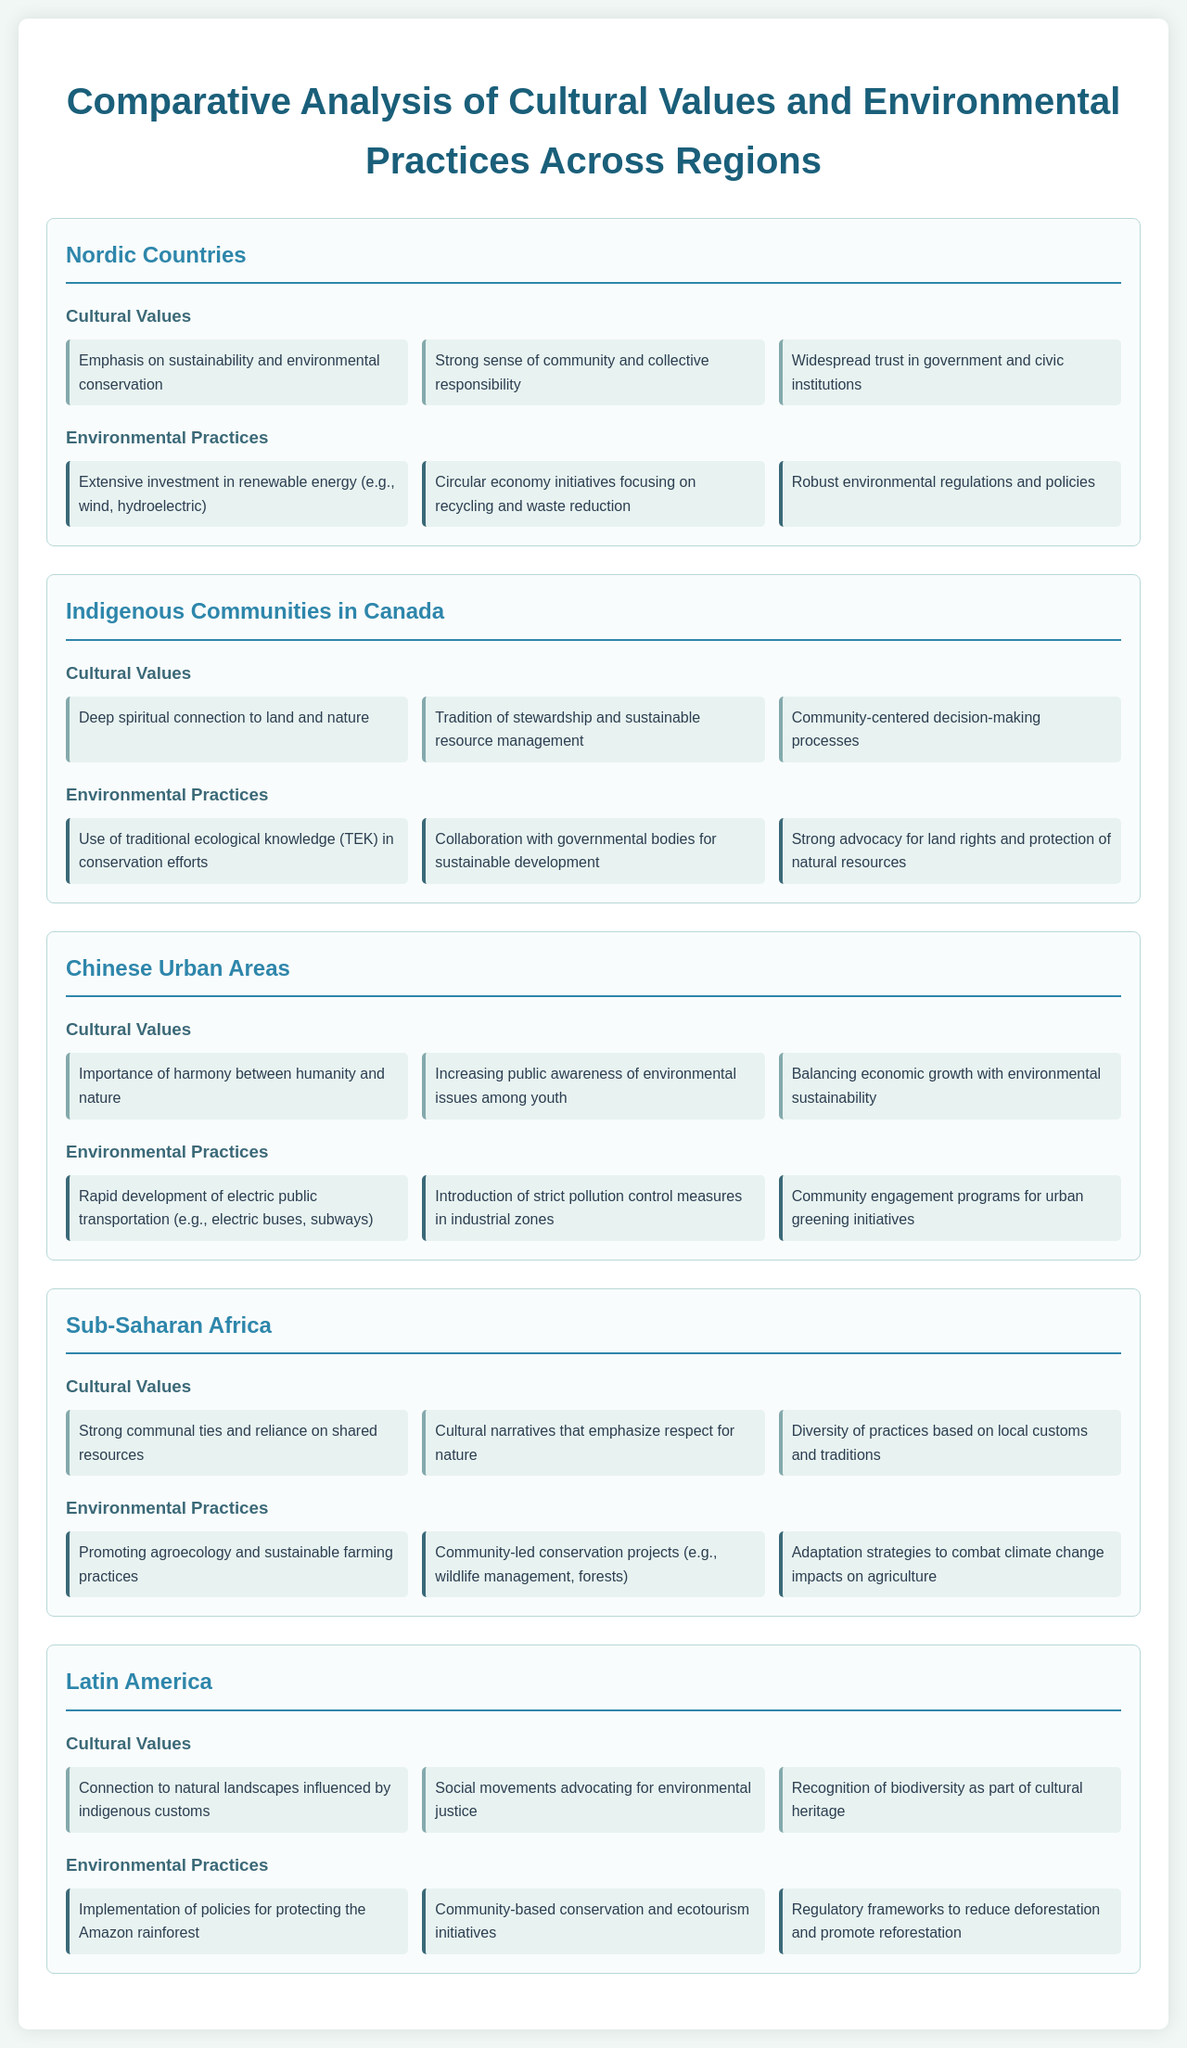What are the cultural values of the Nordic Countries? The cultural values listed for the Nordic Countries are emphasized on sustainability, community responsibility, and trust in government.
Answer: Sustainability and environmental conservation, strong sense of community and collective responsibility, widespread trust in government and civic institutions What type of environmental practice is prominent in Indigenous Communities in Canada? Indigenous Communities in Canada utilize traditional ecological knowledge as a significant environmental practice.
Answer: Use of traditional ecological knowledge (TEK) in conservation efforts How many cultural values are listed for Chinese Urban Areas? The section for Chinese Urban Areas contains three cultural values described in the document.
Answer: Three What cultural value emphasizes respect for nature in Sub-Saharan Africa? The cultural narrative in Sub-Saharan Africa that emphasizes respect for nature is described directly in the document.
Answer: Cultural narratives that emphasize respect for nature Which region advocates for land rights and protection of natural resources? Indigenous Communities in Canada prominently advocate for land rights and the protection of their natural resources.
Answer: Indigenous Communities in Canada What is a key environmental practice in Latin America related to the Amazon rainforest? The document mentions the implementation of policies specifically aimed at protecting the Amazon rainforest in Latin America.
Answer: Implementation of policies for protecting the Amazon rainforest What is a common cultural value found across Sub-Saharan Africa? The document states that strong communal ties and reliance on shared resources are prevalent cultural values in Sub-Saharan Africa.
Answer: Strong communal ties and reliance on shared resources What are the environmental practices focusing on in Nordic Countries? The environmental practices in Nordic Countries revolve around renewable energy investment, recycling, and robust regulations.
Answer: Extensive investment in renewable energy, circular economy initiatives, robust environmental regulations and policies 